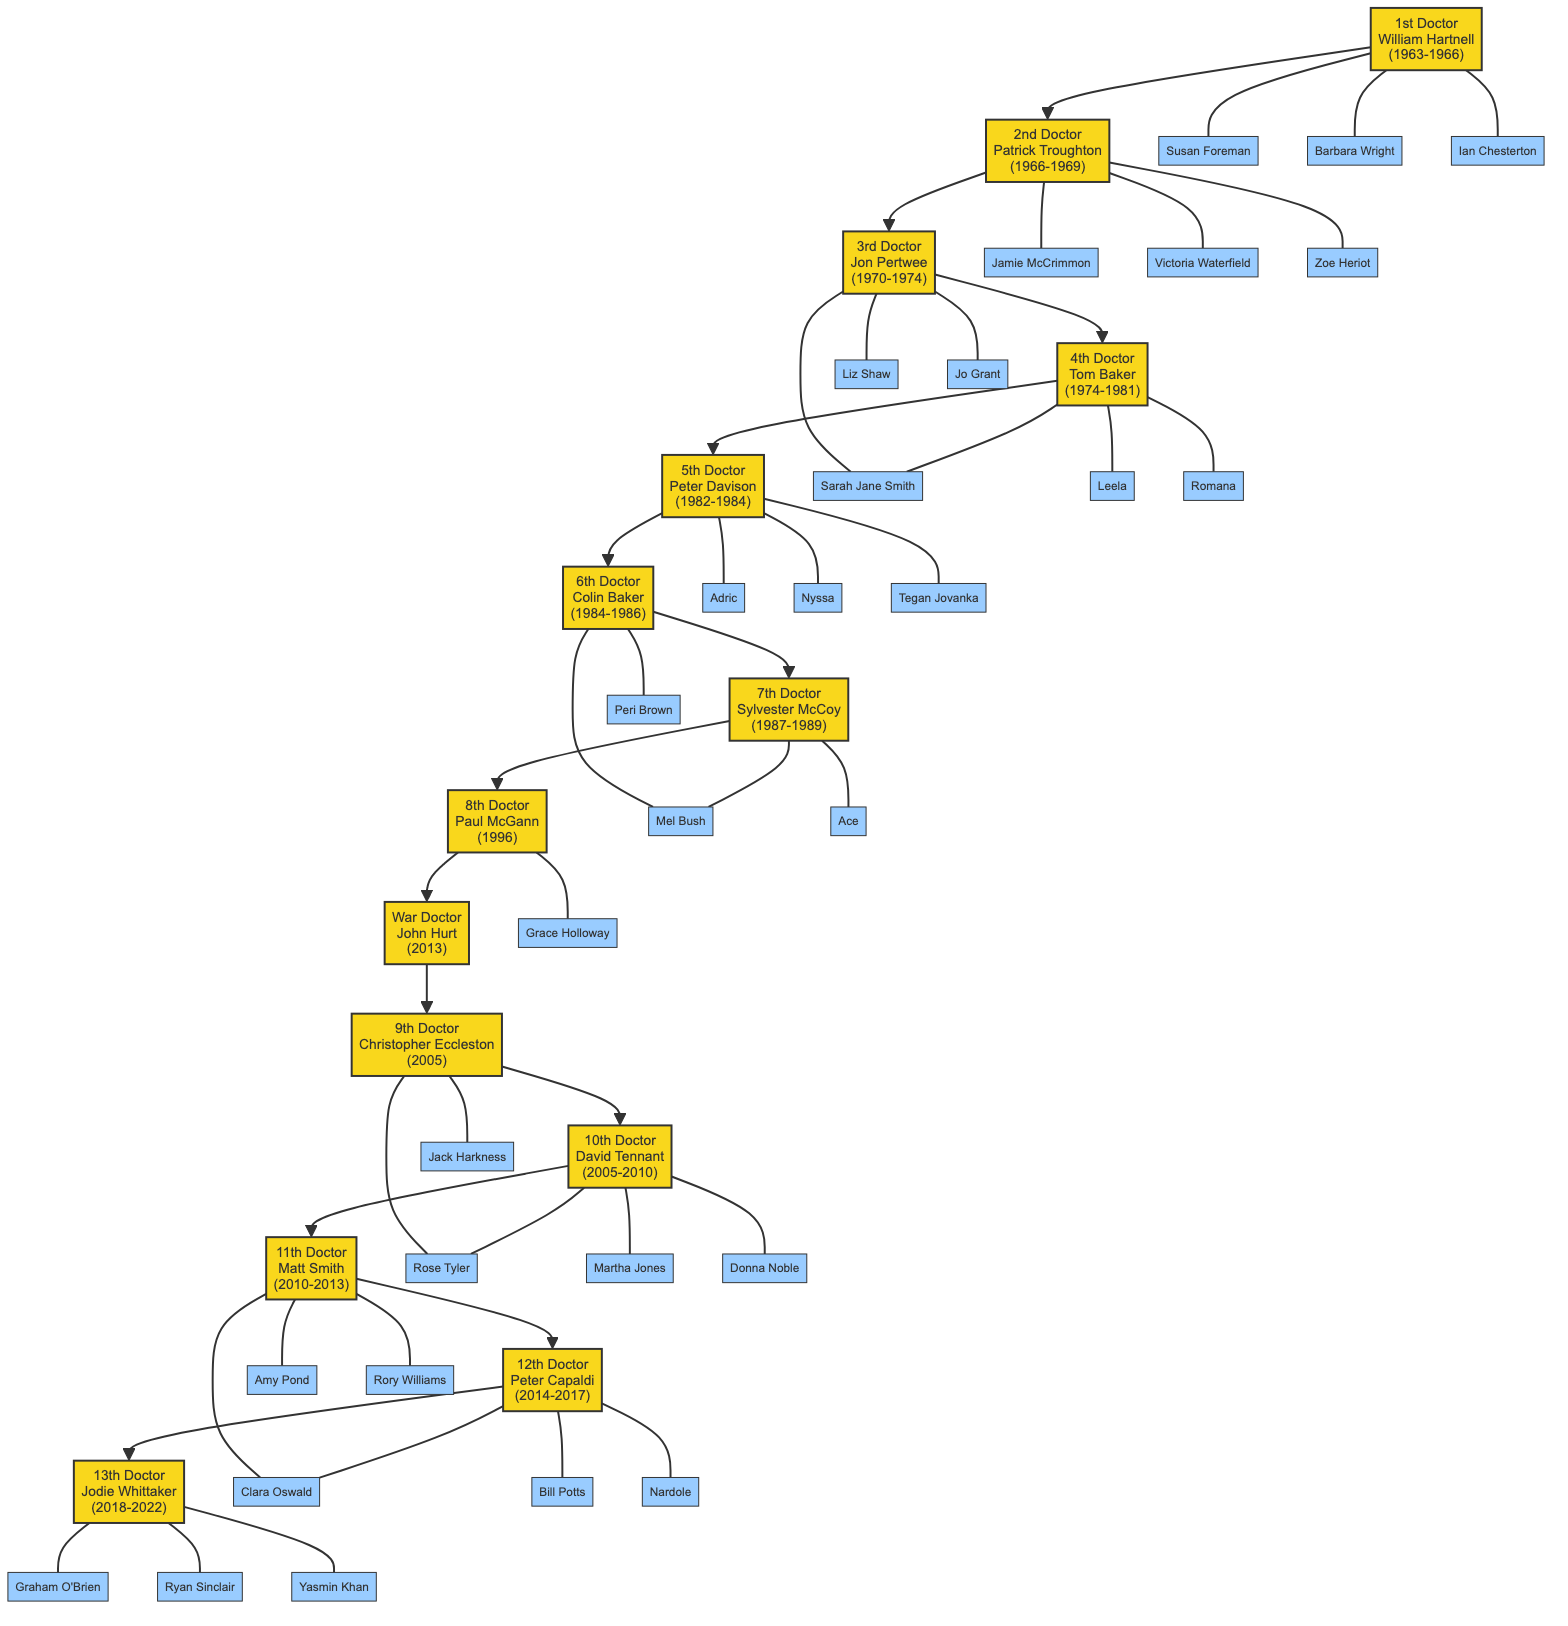What is the name of the 3rd Doctor? To find the name of the 3rd Doctor, look for the node representing the 3rd Doctor in the diagram. The 3rd Doctor's node is labeled "3rd Doctor<br/>Jon Pertwee<br/>(1970-1974)", which shows that the name is Jon Pertwee.
Answer: Jon Pertwee How many companions did the 10th Doctor have? To determine the number of companions for the 10th Doctor, locate the node for the 10th Doctor, which lists three companions: Rose Tyler, Martha Jones, and Donna Noble. Counting these gives a total of three companions.
Answer: 3 Who is the companion shared between the 4th and 3rd Doctors? Looking at the companions of the 4th Doctor, we see Sarah Jane Smith listed. The 3rd Doctor also has Sarah Jane Smith as a companion. Therefore, she is the shared companion.
Answer: Sarah Jane Smith Which Doctor was active during the years 2005-2010? The 10th Doctor's node states he was active from 2005 to 2010, which matches the specified years. Thus, the Doctor who was active during those years is the 10th Doctor.
Answer: 10th Doctor Which Doctor took over directly from the 7th Doctor? The diagram shows a direct line from the 7th Doctor (Sylvester McCoy) to the 8th Doctor (Paul McGann), indicating that Paul McGann took over directly from Sylvester McCoy.
Answer: 8th Doctor How many active doctors are before the 12th Doctor? To find how many Doctors are active before the 12th Doctor, count all the connected nodes before the 12th Doctor's node in the diagram. There are 11 Doctors (from the 1st to the 11th) before the 12th Doctor.
Answer: 11 What is the relationship between the War Doctor and the 9th Doctor? The diagram connects the War Doctor directly to the 9th Doctor. This indicates that the War Doctor comes immediately before the 9th Doctor in the sequence of Doctors.
Answer: Sequential Which Doctor has the most companions listed? When examining the companions of each Doctor, the 10th Doctor has the most (three companions: Rose Tyler, Martha Jones, and Donna Noble) compared to others who have fewer. Therefore, the 10th Doctor has the most companions listed.
Answer: 10th Doctor 